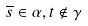<formula> <loc_0><loc_0><loc_500><loc_500>\overline { s } \in \alpha , t \notin \gamma</formula> 